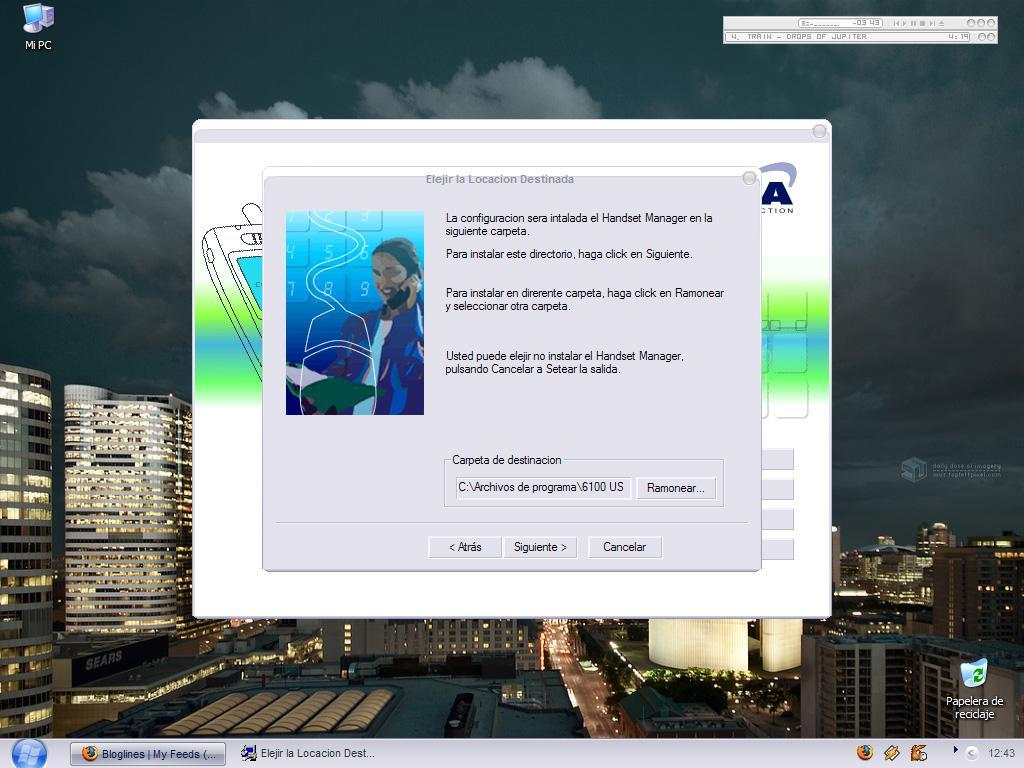What is the main subject of the image? The main subject of the image is the display screen of a desktop. Can you describe the display screen in more detail? Unfortunately, the provided facts do not offer any additional details about the display screen. What type of thunder can be heard coming from the desktop in the image? There is no sound, including thunder, present in the image, as it only features the display screen of a desktop. 